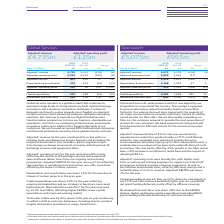According to Bt Group Plc's financial document, What is the  Adjusted a revenue for 2019? According to the financial document, 4,735 (in millions). The relevant text states: "Adjusted a revenue 4,735 5,013 (278) (6)..." Also, What is the reason for Adjusteda operating costs percentage decrease? mainly reflecting the decline in IP Exchange volumes and equipment sales and lower labour costs from our ongoing restructuring programme. The document states: "usted a operating costs for the year were down 8% mainly reflecting the decline in IP Exchange volumes and equipment sales and lower labour costs from..." Also, What is the Capital expenditure for 2019? According to the financial document, 245 (in millions). The relevant text states: "Capital expenditure 245 278 (33) (12)..." Also, can you calculate: What was the average Adjusted EBITDA for 2018 and 2019? To answer this question, I need to perform calculations using the financial data. The calculation is: (505 + 434) / 2, which equals 469.5 (in millions). This is based on the information: "Adjusted a EBITDA 505 434 71 16 Adjusted a EBITDA 505 434 71 16..." The key data points involved are: 434, 505. Also, can you calculate: What  was the EBITDA margin in 2019? Based on the calculation: 505 / 4,735, the result is 0.11. This is based on the information: "Adjusted a EBITDA 505 434 71 16 Adjusted a revenue 4,735 5,013 (278) (6)..." The key data points involved are: 4,735, 505. Also, can you calculate: What is the average Adjusteda operating costs for 2018 and 2019? To answer this question, I need to perform calculations using the financial data. The calculation is: (4,230 + 4,579) / 2, which equals 4404.5 (in millions). This is based on the information: "Adjusted a operating costs 4,230 4,579 (349) (8) Adjusted a operating costs 4,230 4,579 (349) (8)..." The key data points involved are: 4,230, 4,579. 